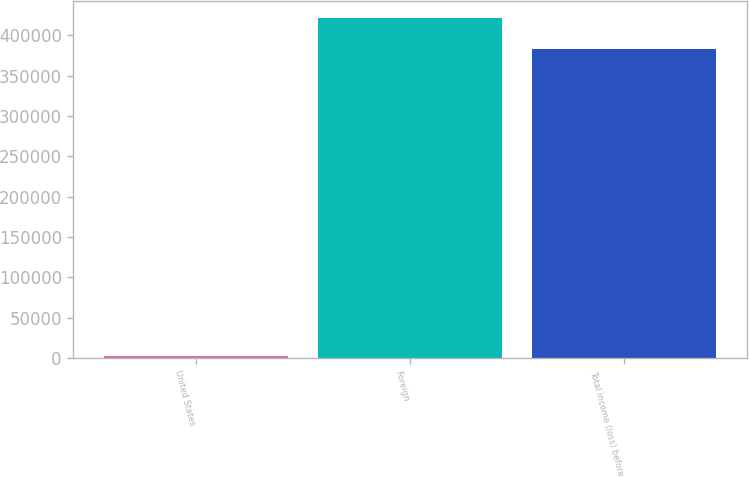Convert chart to OTSL. <chart><loc_0><loc_0><loc_500><loc_500><bar_chart><fcel>United States<fcel>Foreign<fcel>Total income (loss) before<nl><fcel>2702<fcel>421408<fcel>383098<nl></chart> 